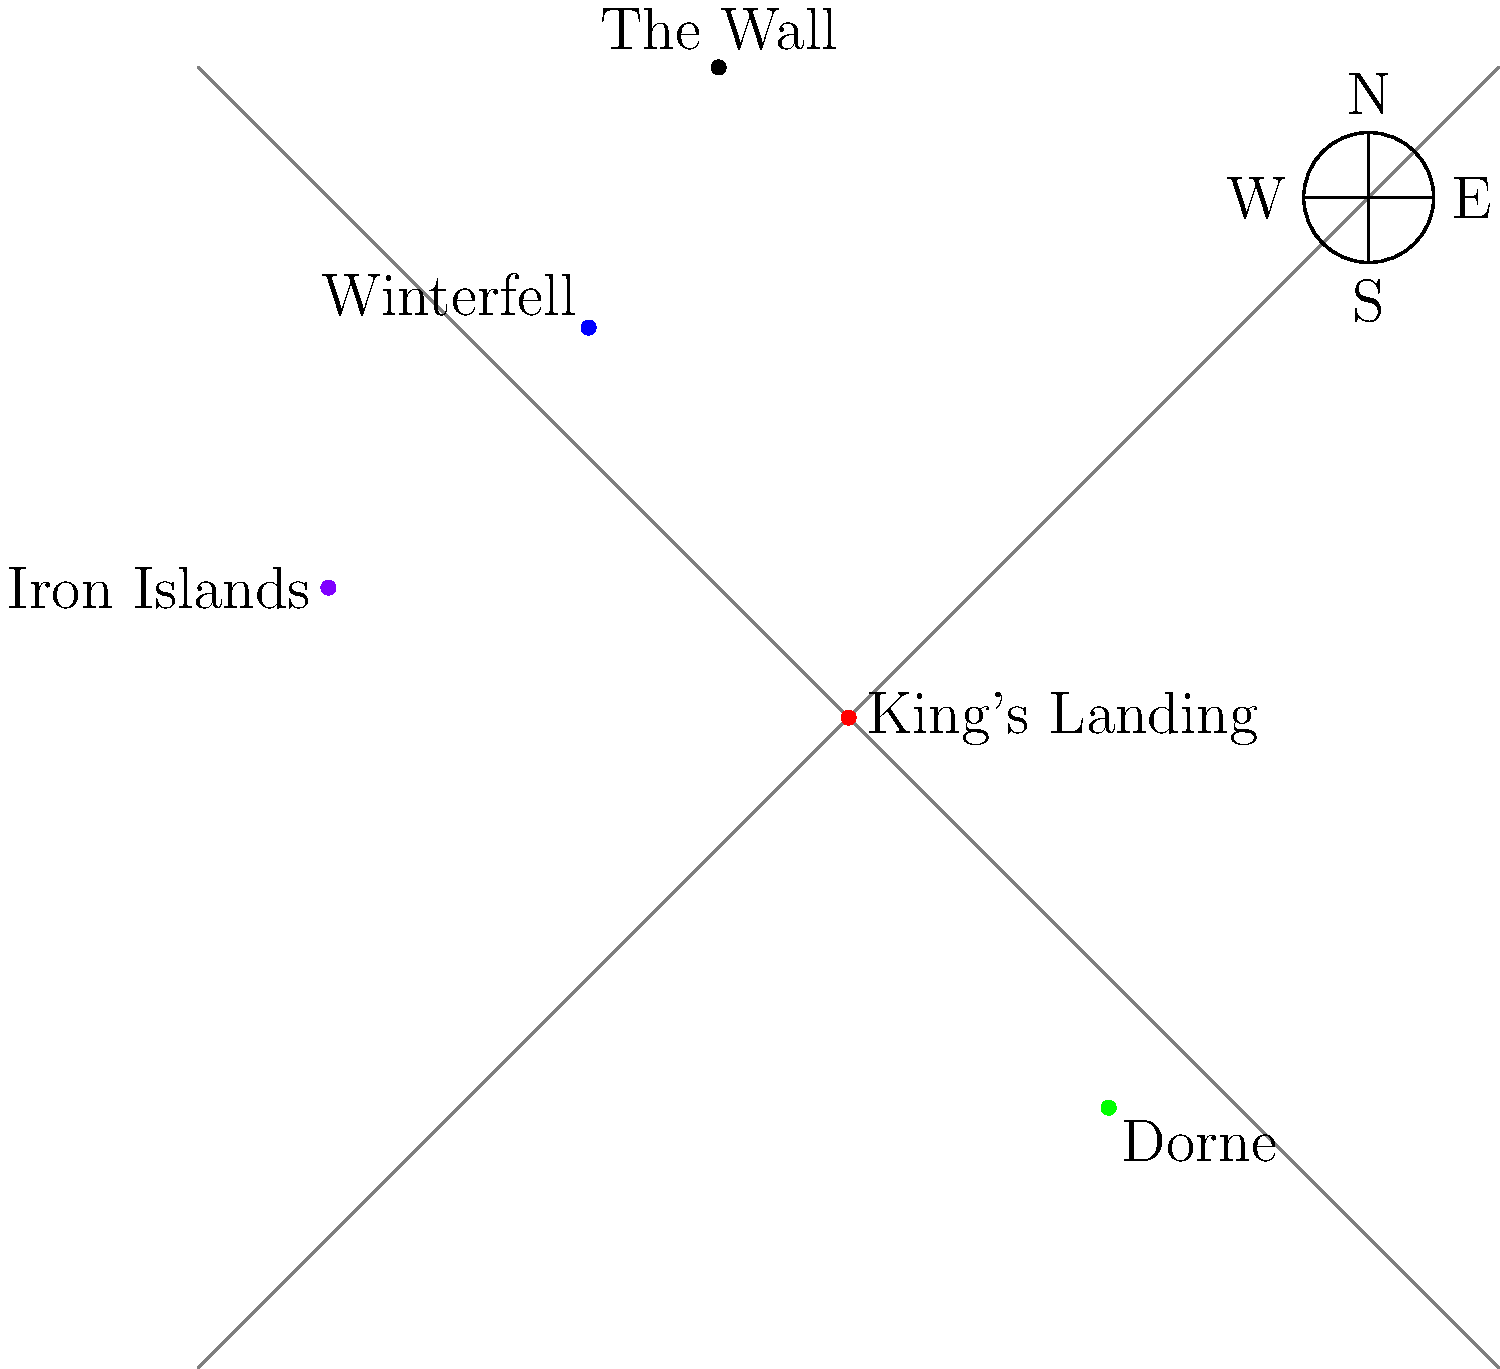Using the stylized map of Westeros provided, calculate the Manhattan distance between King's Landing and Winterfell. Assume each grid unit represents 100 leagues. How does this distance compare to the distance between The Wall and Dorne? To solve this problem, we need to follow these steps:

1. Calculate the Manhattan distance between King's Landing and Winterfell:
   - King's Landing coordinates: (0,0)
   - Winterfell coordinates: (-2,3)
   - Manhattan distance = |x1 - x2| + |y1 - y2|
   - |0 - (-2)| + |0 - 3| = 2 + 3 = 5 grid units

2. Convert grid units to leagues:
   - 1 grid unit = 100 leagues
   - 5 grid units = 5 * 100 = 500 leagues

3. Calculate the Manhattan distance between The Wall and Dorne:
   - The Wall coordinates: (-1,5)
   - Dorne coordinates: (2,-3)
   - Manhattan distance = |(-1) - 2| + |5 - (-3)| = 3 + 8 = 11 grid units
   - 11 grid units = 11 * 100 = 1100 leagues

4. Compare the distances:
   - King's Landing to Winterfell: 500 leagues
   - The Wall to Dorne: 1100 leagues
   - The distance between The Wall and Dorne is 1100 / 500 = 2.2 times greater than the distance between King's Landing and Winterfell.
Answer: 500 leagues; 2.2 times greater 